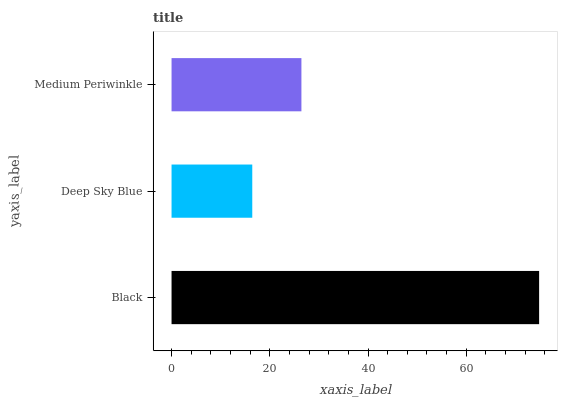Is Deep Sky Blue the minimum?
Answer yes or no. Yes. Is Black the maximum?
Answer yes or no. Yes. Is Medium Periwinkle the minimum?
Answer yes or no. No. Is Medium Periwinkle the maximum?
Answer yes or no. No. Is Medium Periwinkle greater than Deep Sky Blue?
Answer yes or no. Yes. Is Deep Sky Blue less than Medium Periwinkle?
Answer yes or no. Yes. Is Deep Sky Blue greater than Medium Periwinkle?
Answer yes or no. No. Is Medium Periwinkle less than Deep Sky Blue?
Answer yes or no. No. Is Medium Periwinkle the high median?
Answer yes or no. Yes. Is Medium Periwinkle the low median?
Answer yes or no. Yes. Is Black the high median?
Answer yes or no. No. Is Deep Sky Blue the low median?
Answer yes or no. No. 